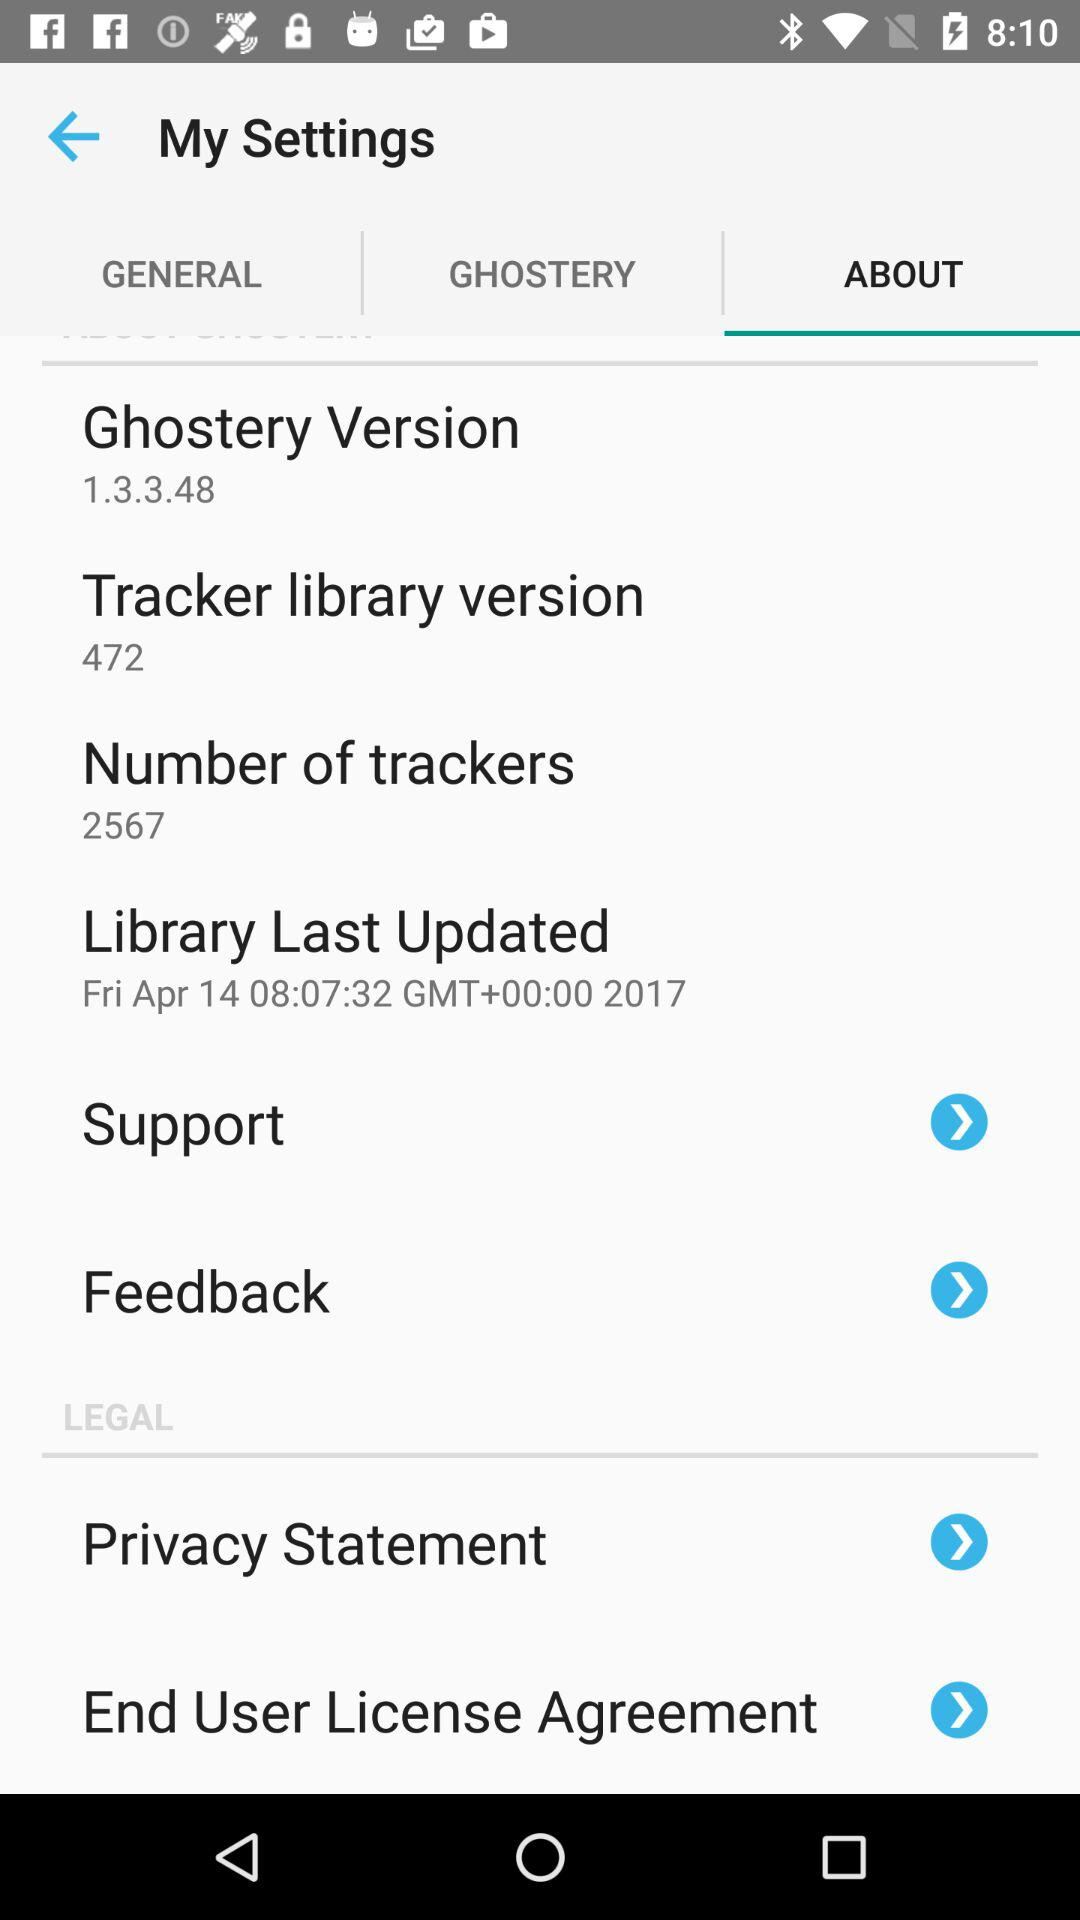When was the last time the library was updated? The library was last updated at 08:07:32 in Greenwich Mean Time. 